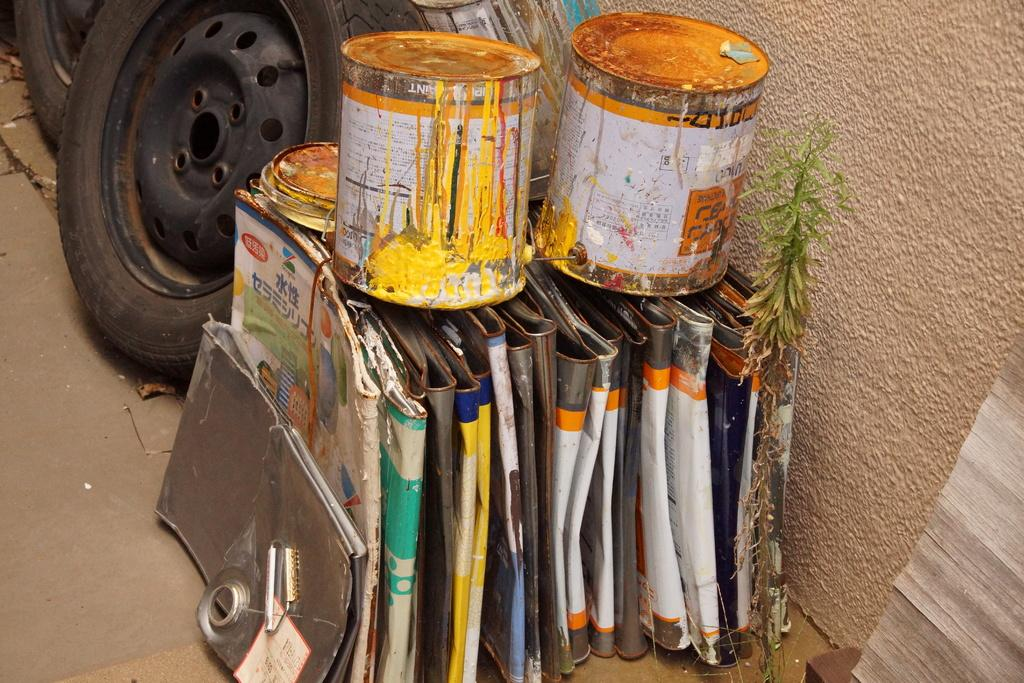What type of material is the main subject of the image made of? There is a group of metal sheets in the image. Are there any living organisms present in the image? Yes, there is a plant in the image. What type of storage containers can be seen in the image? There are containers with lids in the image. What other type of material is present in the image? There is a wooden sheet in the image. What objects are placed on the surface in the image? There are tires placed on the surface in the image. What can be seen in the background of the image? There is a wall in the background of the image. What type of music is the band playing in the image? There is no band present in the image, so it is not possible to determine what type of music they might be playing. 